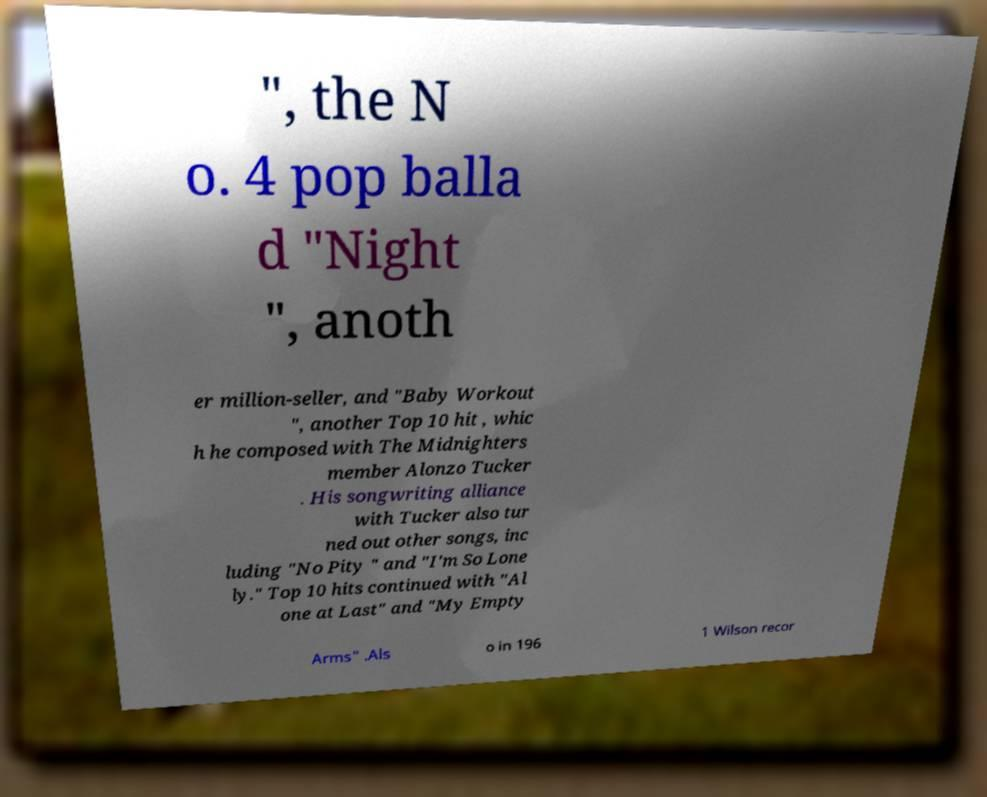I need the written content from this picture converted into text. Can you do that? ", the N o. 4 pop balla d "Night ", anoth er million-seller, and "Baby Workout ", another Top 10 hit , whic h he composed with The Midnighters member Alonzo Tucker . His songwriting alliance with Tucker also tur ned out other songs, inc luding "No Pity " and "I'm So Lone ly." Top 10 hits continued with "Al one at Last" and "My Empty Arms" .Als o in 196 1 Wilson recor 